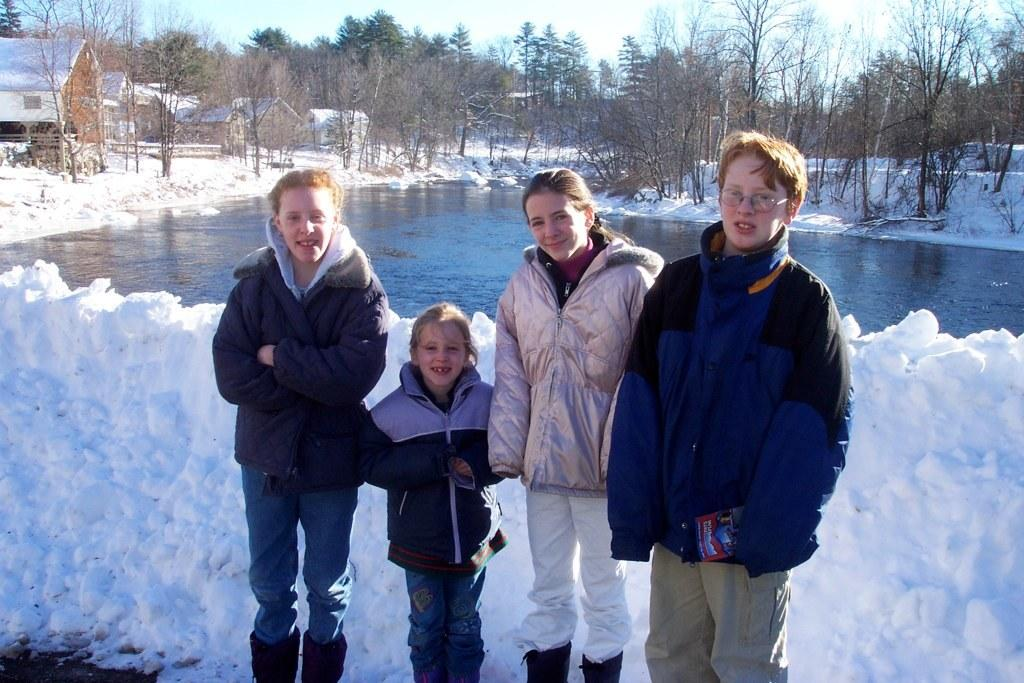How many people are present in the image? There are four people standing in the image. What can be seen in the background of the image? There is snow, water, trees, houses, and the sky visible in the background of the image. What type of soup is being served in the image? There is no soup present in the image. How many beds can be seen in the image? There are no beds visible in the image. 